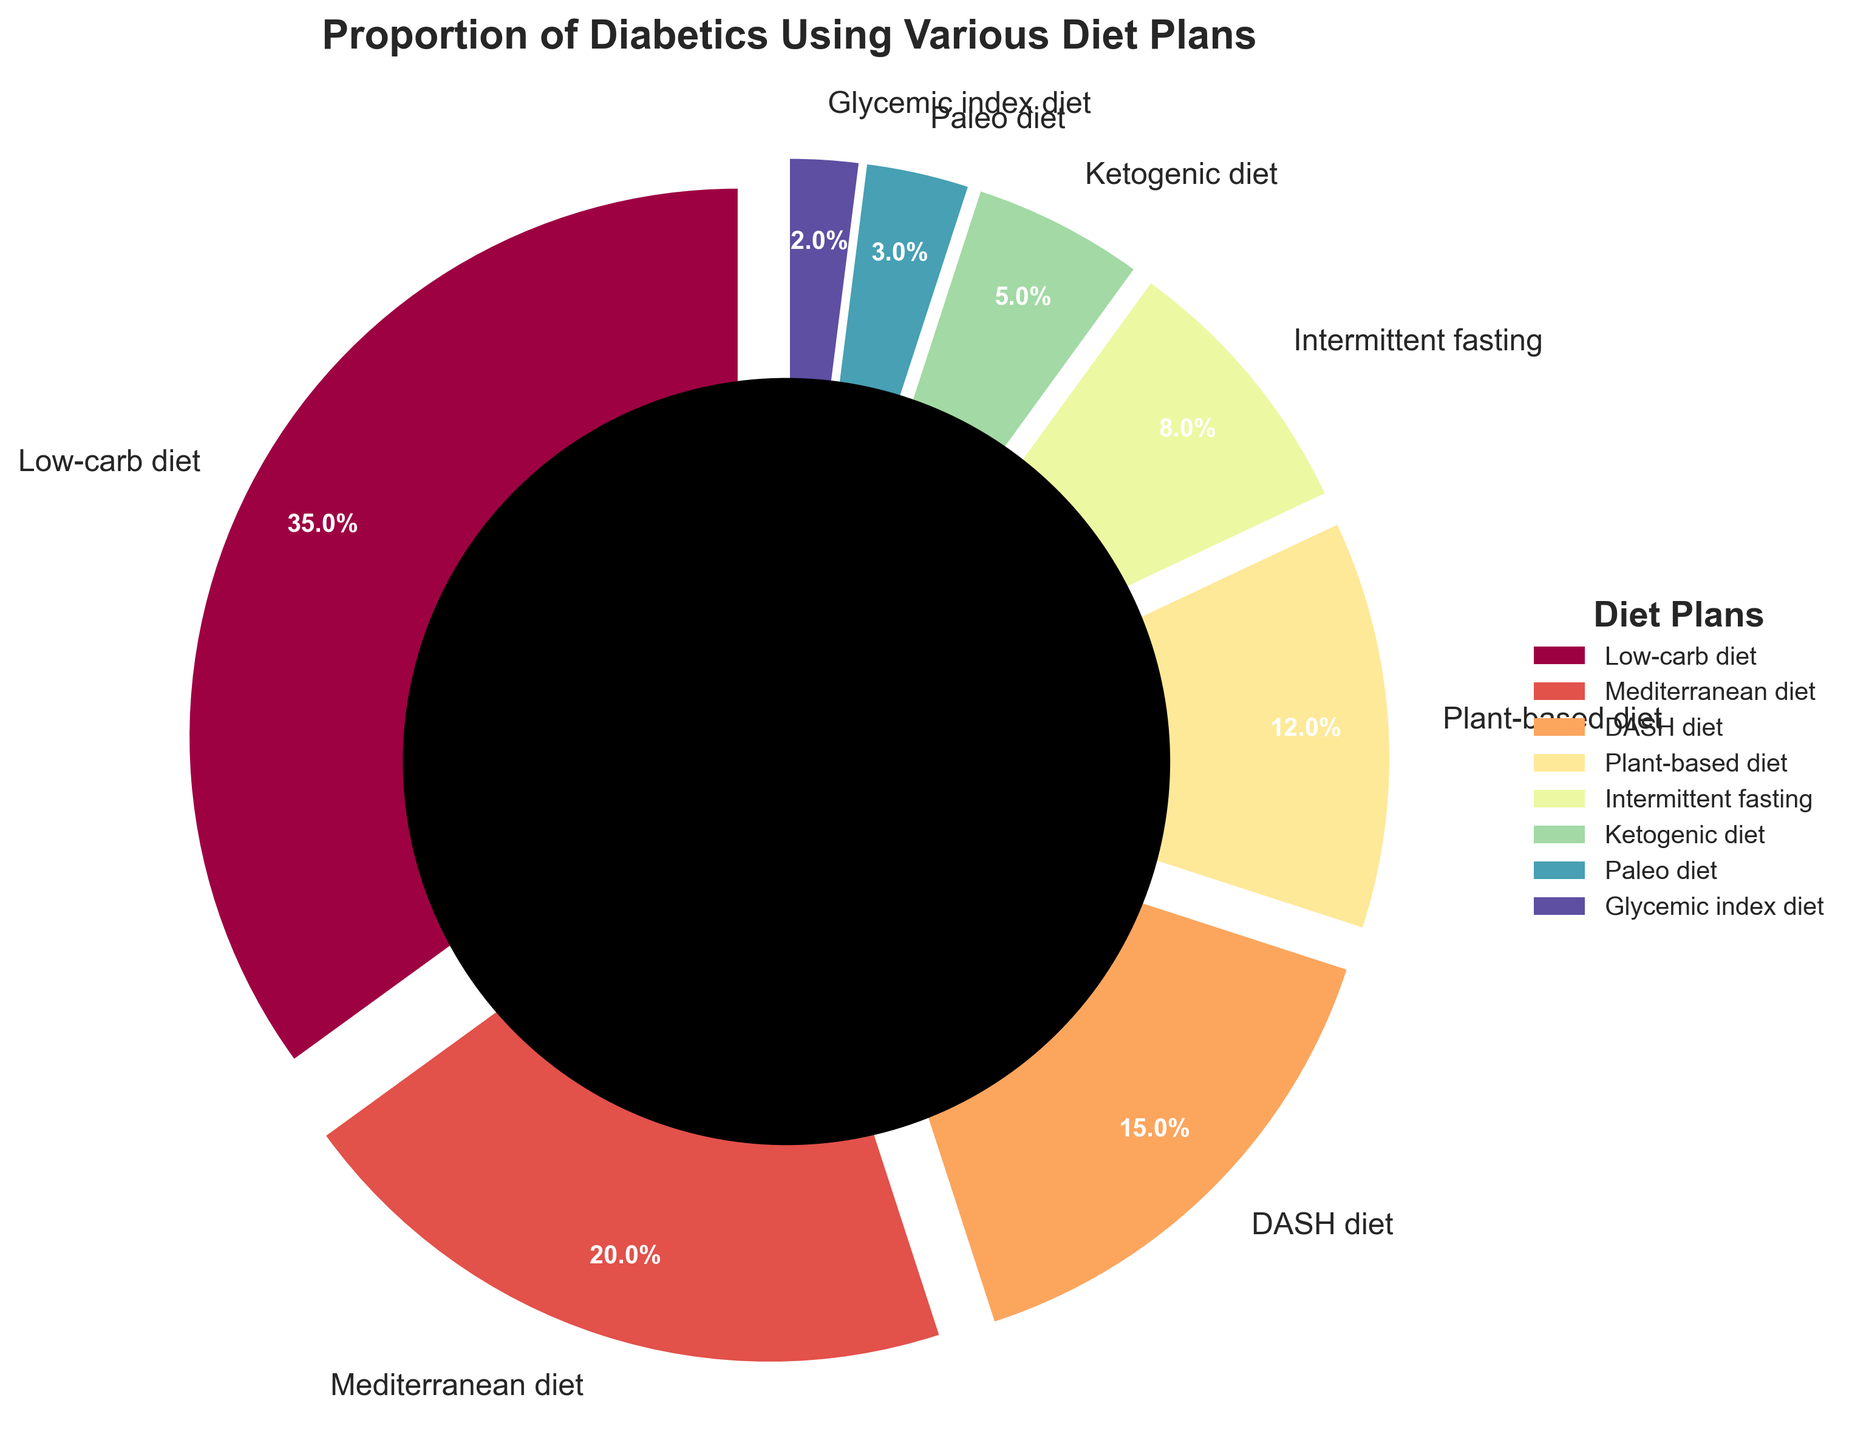What's the total percentage of diabetics using Plant-based and Ketogenic diets? To find the total percentage of diabetics using Plant-based and Ketogenic diets, add the percentages for these two diet plans. The percentage for Plant-based diet is 12 and for Ketogenic diet is 5. So, 12 + 5 = 17.
Answer: 17 Which diet plan has the highest proportion of users? Look at the pie chart and identify the diet plan with the largest slice. The Low-carb diet has the highest proportion with 35%.
Answer: Low-carb diet How does the percentage of people following the Paleo diet compare to those following the DASH diet? Identify the percentages for the Paleo diet and the DASH diet from the chart. The Paleo diet has 3%, and the DASH diet has 15%. Comparing these, the DASH diet has a higher percentage.
Answer: DASH diet has a higher percentage Which diet plans are used by less than 10% of diabetics? From the pie chart, identify diet plans that have slices representing less than 10% of the total. Intermittent fasting (8%), Ketogenic diet (5%), Paleo diet (3%), and Glycemic index diet (2%) are less than 10%.
Answer: Intermittent fasting, Ketogenic diet, Paleo diet, Glycemic index diet What percentage of diabetics use either the Mediterranean diet or the DASH diet? Add the percentages for the Mediterranean diet and the DASH diet. Mediterranean diet is 20%, and DASH diet is 15%. So, 20 + 15 = 35.
Answer: 35 Compare the proportion of diabetics using the Mediterranean diet to those using intermittent fasting. Identify the percentages for the Mediterranean diet and intermittent fasting from the chart. The Mediterranean diet has 20%, intermittent fasting has 8%. Comparing these, the Mediterranean diet has a higher percentage.
Answer: Mediterranean diet has a higher percentage What is the smallest proportion of any diet plan, and which diet plan is it? Identify the diet plan and its percentage with the smallest slice in the pie chart. The Glycemic index diet is the smallest with 2%.
Answer: Glycemic index diet with 2% Is the percentage of people using the Low-carb diet more than the combined percentages of the DASH diet and Plant-based diet? Identify the percentages for the Low-carb diet, DASH diet, and Plant-based diet from the chart. Low-carb diet is 35%, DASH diet is 15%, and Plant-based diet is 12%. Adding DASH diet and Plant-based diet gives 15 + 12 = 27%. 35% (Low-carb) is more than 27%.
Answer: Yes, it is more What is the difference in the percentage of diabetics using Plant-based and Intermittent fasting diets? Subtract the percentage of Intermittent fasting from Plant-based diet. The percentage of Plant-based diet is 12%, and Intermittent fasting is 8%. So, 12 - 8 = 4.
Answer: 4 Which diet plans together account for more than half of the diabetes diet plans? Add the percentages of the diet plans until the total exceeds 50%. Low-carb diet (35%), Mediterranean diet (20%) together account for 35 + 20 = 55%, which is more than half.
Answer: Low-carb diet and Mediterranean diet 